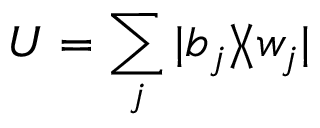Convert formula to latex. <formula><loc_0><loc_0><loc_500><loc_500>U = \sum _ { j } | b _ { j } \rangle \, \langle w _ { j } |</formula> 